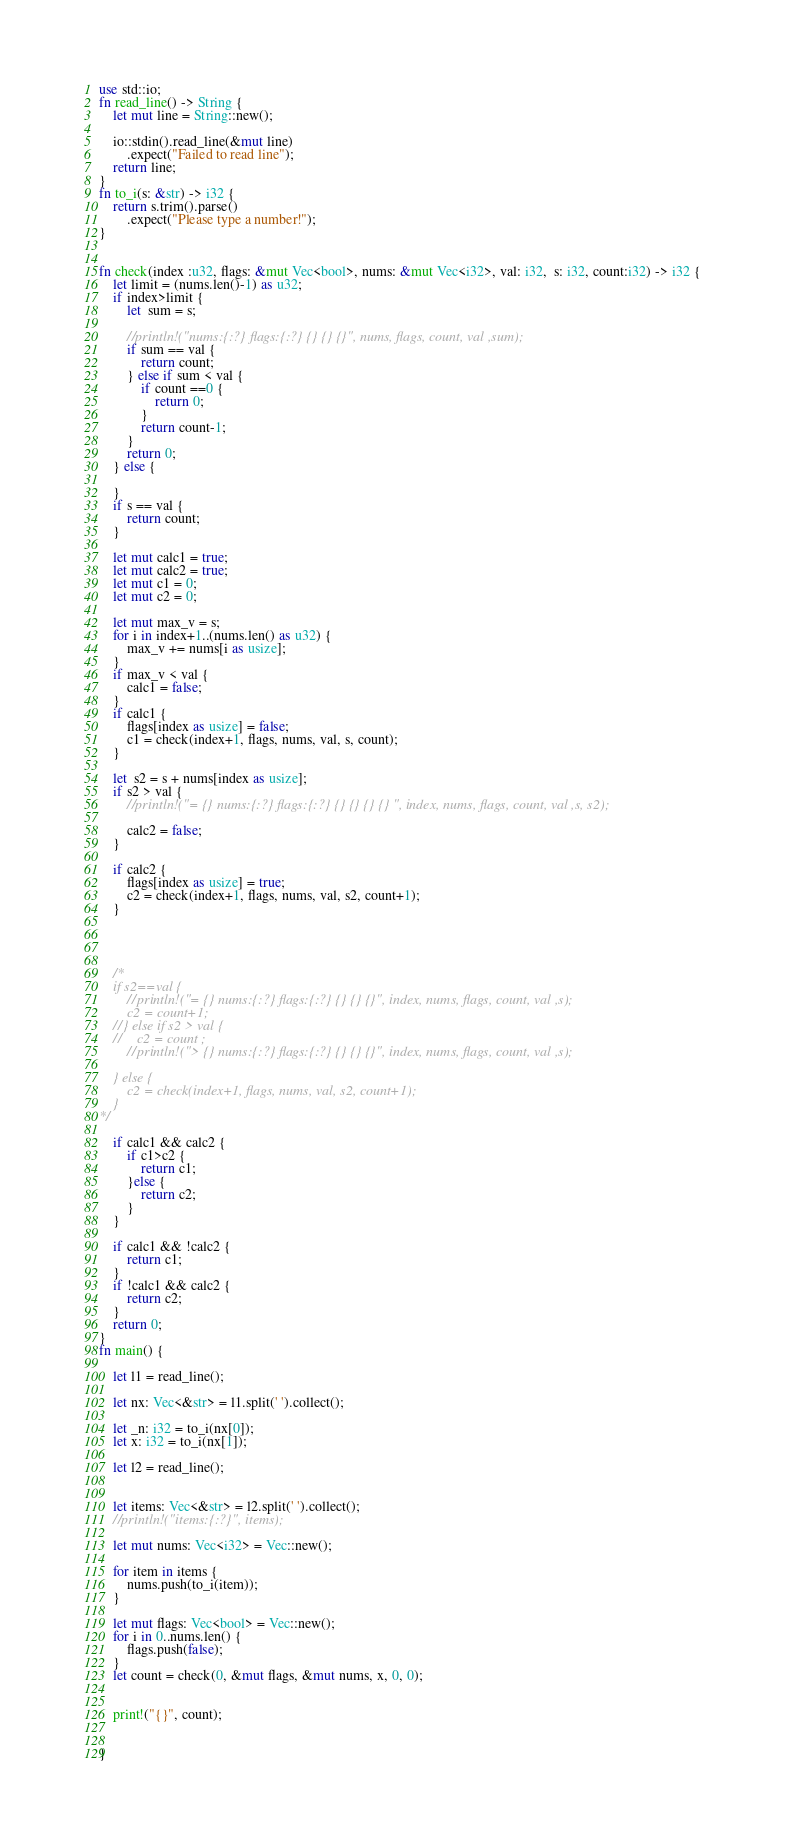<code> <loc_0><loc_0><loc_500><loc_500><_Rust_>use std::io;
fn read_line() -> String {
    let mut line = String::new();

    io::stdin().read_line(&mut line)
        .expect("Failed to read line");
    return line;
}
fn to_i(s: &str) -> i32 {
    return s.trim().parse()
        .expect("Please type a number!");
}


fn check(index :u32, flags: &mut Vec<bool>, nums: &mut Vec<i32>, val: i32,  s: i32, count:i32) -> i32 {
    let limit = (nums.len()-1) as u32;
    if index>limit {
        let  sum = s;
       
        //println!("nums:{:?} flags:{:?} {} {} {}", nums, flags, count, val ,sum);
        if sum == val {
            return count;
        } else if sum < val {
            if count ==0 {
                return 0;
            }
            return count-1;
        }
        return 0;
    } else {
        
    }
    if s == val {
        return count;
    }
    
    let mut calc1 = true;
    let mut calc2 = true;
    let mut c1 = 0;
    let mut c2 = 0;

    let mut max_v = s;
    for i in index+1..(nums.len() as u32) {
        max_v += nums[i as usize];
    }
    if max_v < val {
        calc1 = false;
    }
    if calc1 {
        flags[index as usize] = false;
        c1 = check(index+1, flags, nums, val, s, count);
    }

    let  s2 = s + nums[index as usize];
    if s2 > val {
        //println!("= {} nums:{:?} flags:{:?} {} {} {} {} ", index, nums, flags, count, val ,s, s2);
            
        calc2 = false;
    }

    if calc2 {
        flags[index as usize] = true;
        c2 = check(index+1, flags, nums, val, s2, count+1);
    }

    

    
    /*
    if s2==val {
        //println!("= {} nums:{:?} flags:{:?} {} {} {}", index, nums, flags, count, val ,s);
        c2 = count+1;
    //} else if s2 > val {
    //    c2 = count ;
        //println!("> {} nums:{:?} flags:{:?} {} {} {}", index, nums, flags, count, val ,s);
        
    } else {
        c2 = check(index+1, flags, nums, val, s2, count+1);
    }
*/

    if calc1 && calc2 {
        if c1>c2 {
            return c1;
        }else {
            return c2;
        }
    }

    if calc1 && !calc2 {
        return c1;
    }
    if !calc1 && calc2 {
        return c2;
    }
    return 0;
}
fn main() {

    let l1 = read_line();
    
    let nx: Vec<&str> = l1.split(' ').collect();

    let _n: i32 = to_i(nx[0]);
    let x: i32 = to_i(nx[1]);

    let l2 = read_line();
    

    let items: Vec<&str> = l2.split(' ').collect();
    //println!("items:{:?}", items);

    let mut nums: Vec<i32> = Vec::new();

    for item in items {
        nums.push(to_i(item));
    }

    let mut flags: Vec<bool> = Vec::new();
    for i in 0..nums.len() {
        flags.push(false);
    }
    let count = check(0, &mut flags, &mut nums, x, 0, 0);


    print!("{}", count);


}   </code> 